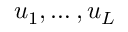Convert formula to latex. <formula><loc_0><loc_0><loc_500><loc_500>u _ { 1 } , \dots , u _ { L }</formula> 